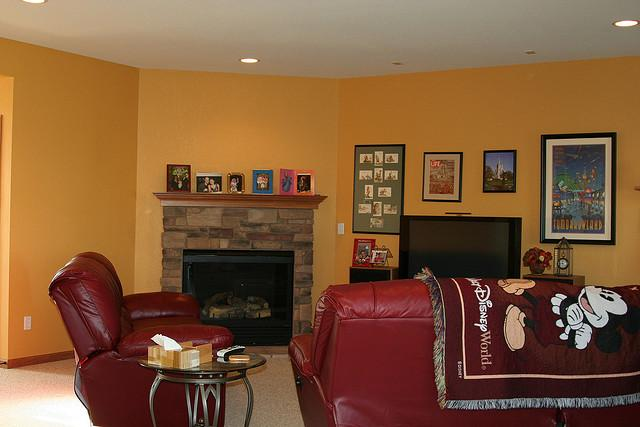What natural element might be found here?

Choices:
A) earth
B) air
C) water
D) fire fire 